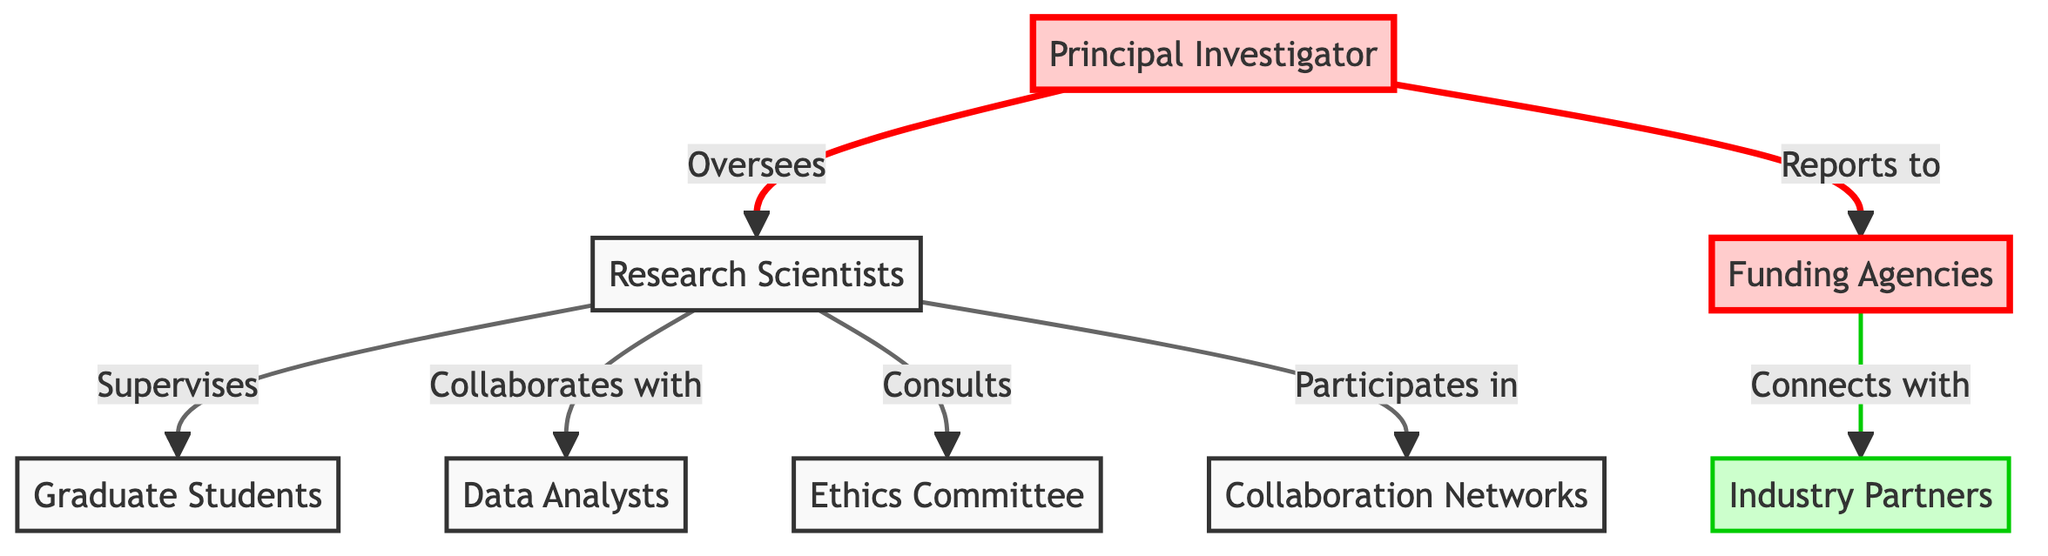What is the total number of nodes in the diagram? The diagram lists eight entities: Principal Investigator, Research Scientists, Data Analysts, Graduate Students, Industry Partners, Funding Agencies, Ethics Committee, and Collaboration Networks. By counting these nodes, we establish that there are eight in total.
Answer: Eight Who oversees the Research Scientists? The directed edge from the Principal Investigator to Research Scientists indicates an overseeing relationship, meaning the Principal Investigator supervises this group.
Answer: Principal Investigator Which node connects with Industry Partners? Funding Agencies is directly linked to Industry Partners, as indicated by the directed edge. This shows that the Funding Agencies have a connection to the Industry Partners.
Answer: Funding Agencies How many relationships involve Research Scientists? Research Scientists are involved in four distinct directed relationships, specifically with Graduate Students, Data Analysts, Ethics Committee, and Collaboration Networks. By examining the outgoing edges from Research Scientists, we find these four connections.
Answer: Four Which node is consulted by Research Scientists? The directed edge from Research Scientists to Ethics Committee indicates that Research Scientists consult with this committee, meaning that it is an essential resource for their decisions or approvals.
Answer: Ethics Committee What role does the Principal Investigator have concerning Funding Agencies? The Principal Investigator reports to Funding Agencies, as shown by the directed edge leading from the former to the latter, establishing a reporting relationship.
Answer: Reports to Which group supervises Graduate Students? The directed edge from Research Scientists to Graduate Students identifies the supervisory role of Research Scientists over Graduate Students. Hence, the responsible group for supervising them is the Research Scientists.
Answer: Research Scientists Count the number of edges in the diagram. The edges represent the directed relationships and connections among the nodes. By reviewing the provided relationships, we see there are seven directed edges in total connecting the different nodes.
Answer: Seven What is the connection type between Funding Agencies and Industry Partners? The connection is characterized by the directed edge, representing a collaboration or partnership between the Funding Agencies and Industry Partners, indicating a cooperative relationship.
Answer: Connects with 